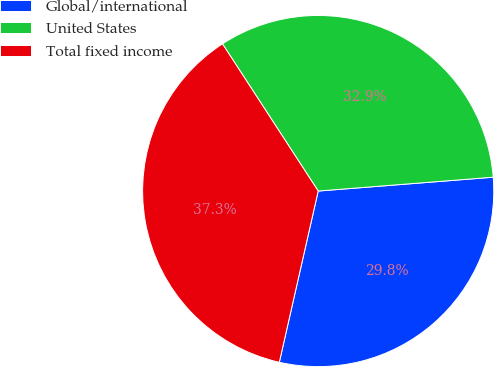Convert chart to OTSL. <chart><loc_0><loc_0><loc_500><loc_500><pie_chart><fcel>Global/international<fcel>United States<fcel>Total fixed income<nl><fcel>29.81%<fcel>32.92%<fcel>37.27%<nl></chart> 